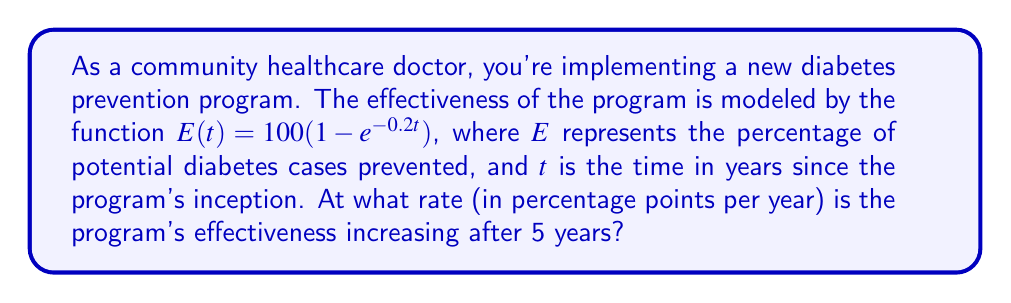Can you solve this math problem? To find the rate at which the program's effectiveness is increasing after 5 years, we need to evaluate the derivative of $E(t)$ at $t=5$. Let's proceed step-by-step:

1) First, let's find the derivative of $E(t)$:
   $$\frac{d}{dt}E(t) = \frac{d}{dt}[100(1 - e^{-0.2t})]$$
   $$E'(t) = 100 \cdot \frac{d}{dt}[1 - e^{-0.2t}]$$
   $$E'(t) = 100 \cdot (-1) \cdot (-0.2e^{-0.2t})$$
   $$E'(t) = 20e^{-0.2t}$$

2) Now, we evaluate $E'(t)$ at $t=5$:
   $$E'(5) = 20e^{-0.2(5)}$$
   $$E'(5) = 20e^{-1}$$

3) Calculate the value:
   $$E'(5) = 20 \cdot \frac{1}{e} \approx 7.3576$$

The derivative $E'(t)$ gives us the instantaneous rate of change of the program's effectiveness. At $t=5$ years, this rate is approximately 7.3576 percentage points per year.
Answer: 7.3576 percentage points per year 